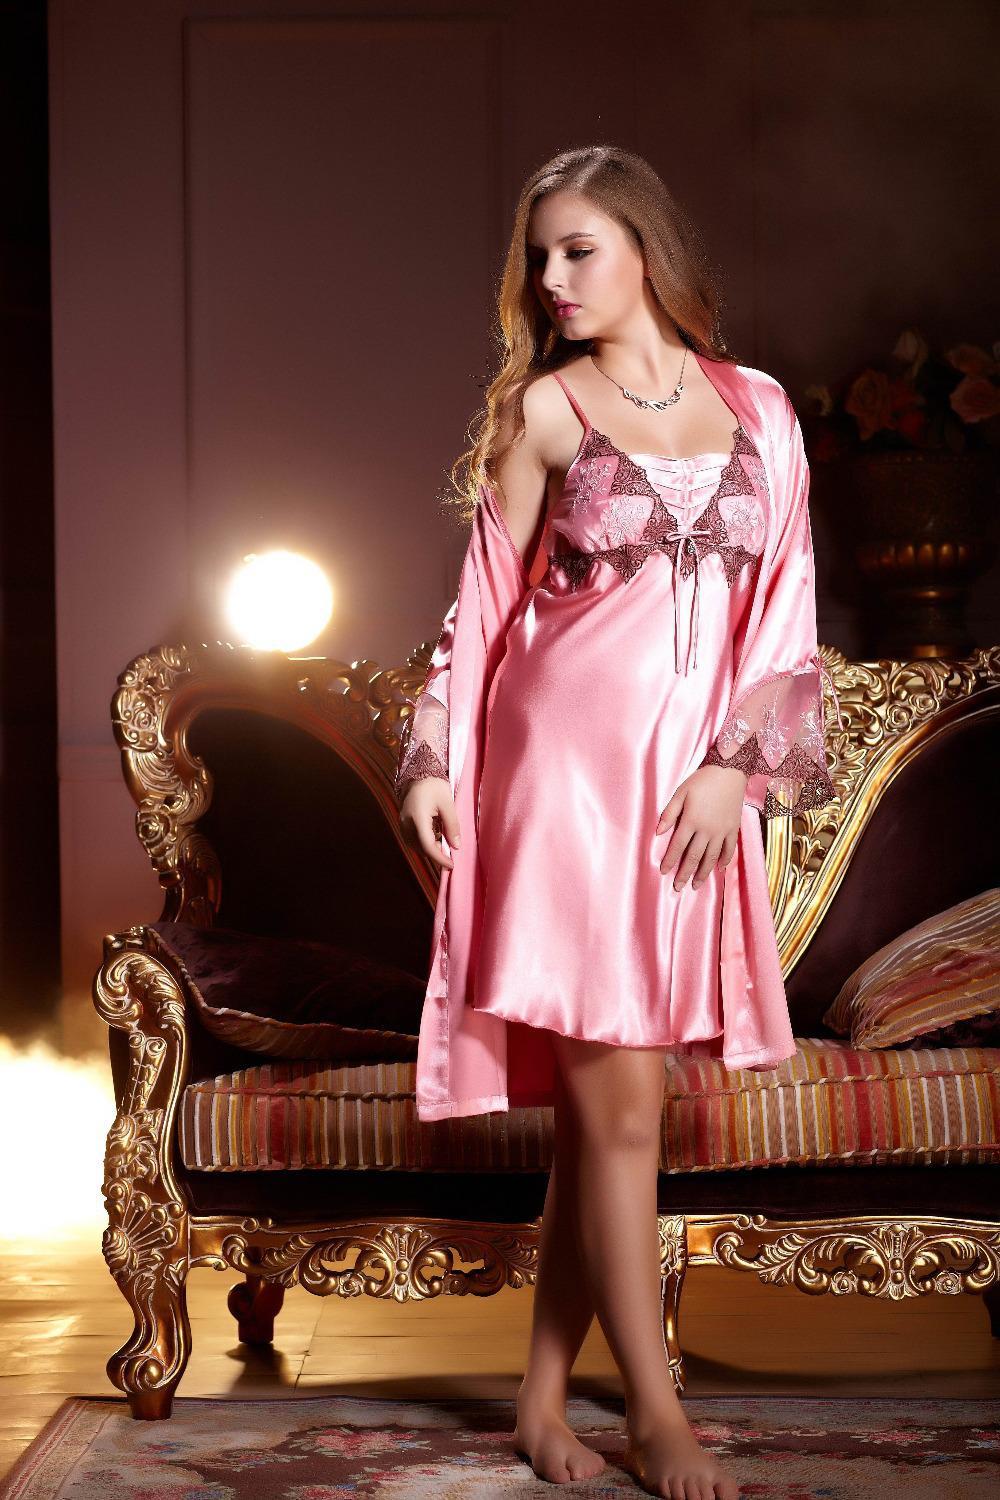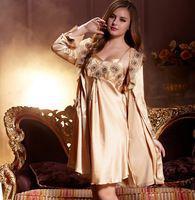The first image is the image on the left, the second image is the image on the right. Evaluate the accuracy of this statement regarding the images: "In one of the images, the girl is sitting down". Is it true? Answer yes or no. No. The first image is the image on the left, the second image is the image on the right. Evaluate the accuracy of this statement regarding the images: "One woman is sitting on something.". Is it true? Answer yes or no. No. 